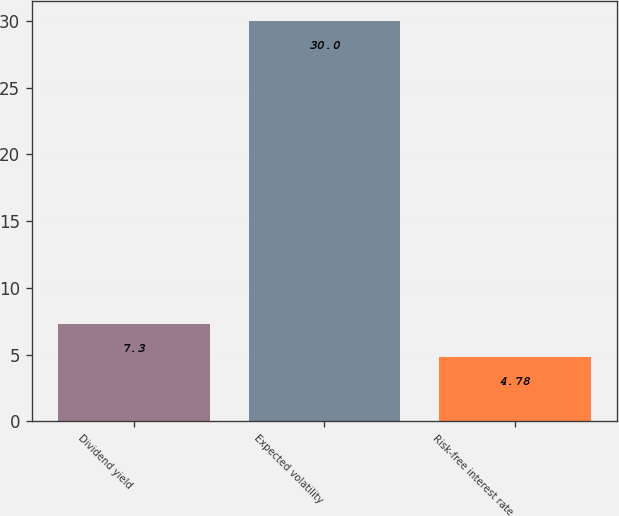Convert chart. <chart><loc_0><loc_0><loc_500><loc_500><bar_chart><fcel>Dividend yield<fcel>Expected volatility<fcel>Risk-free interest rate<nl><fcel>7.3<fcel>30<fcel>4.78<nl></chart> 